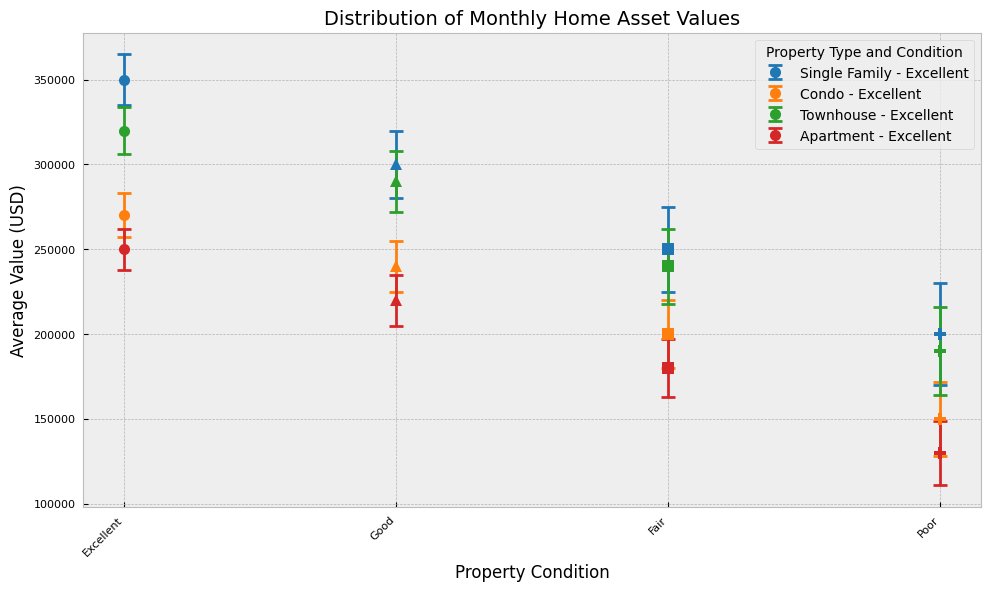What is the average value of a Single Family home in Excellent condition? To find this answer, locate the data point for "Single Family" under the "Excellent" condition in the chart. The plot will display the average value along with error bars indicating the standard deviation.
Answer: 350,000 Which property type has the lowest average value in Poor condition? Focus on the "Poor" condition for each property type in the chart. Compare the average values visually to determine which has the smallest value.
Answer: Apartment What is the difference in average value between an Excellent Condo and a Good Townhouse? First, find the average value for "Condo" in "Excellent" condition and for "Townhouse" in "Good" condition. Subtract the average value of the Good Townhouse from the Excellent Condo.
Answer: 270,000 - 290,000 = (20,000) Which property type in Excellent condition has the highest average value? Search the chart for all property types under the "Excellent" condition, then compare their average values to determine the highest.
Answer: Single Family How much higher is the average value of a Single Family home in Good condition compared to an Apartment in Poor condition? Locate the average value for "Single Family" in "Good" condition and "Apartment" in "Poor" condition on the chart. Subtract the latter from the former to get the difference.
Answer: 300,000 - 130,000 = 170,000 What color is used to represent Townhouses in the plot? Identify the color coding used for the property types in the chart. Look for the label indicating "Townhouse" and note its color.
Answer: Green Which property type has the most significant error bar width in Fair condition? Examine the error bars for all property types under the "Fair" condition and determine which one has the longest error bar, indicating the largest standard deviation.
Answer: Single Family What is the range of average values for Condos across all conditions? Find the highest and lowest average values for "Condo" in the chart, regardless of condition. Subtract the minimum value from the maximum to calculate the range.
Answer: 270,000 - 150,000 = 120,000 